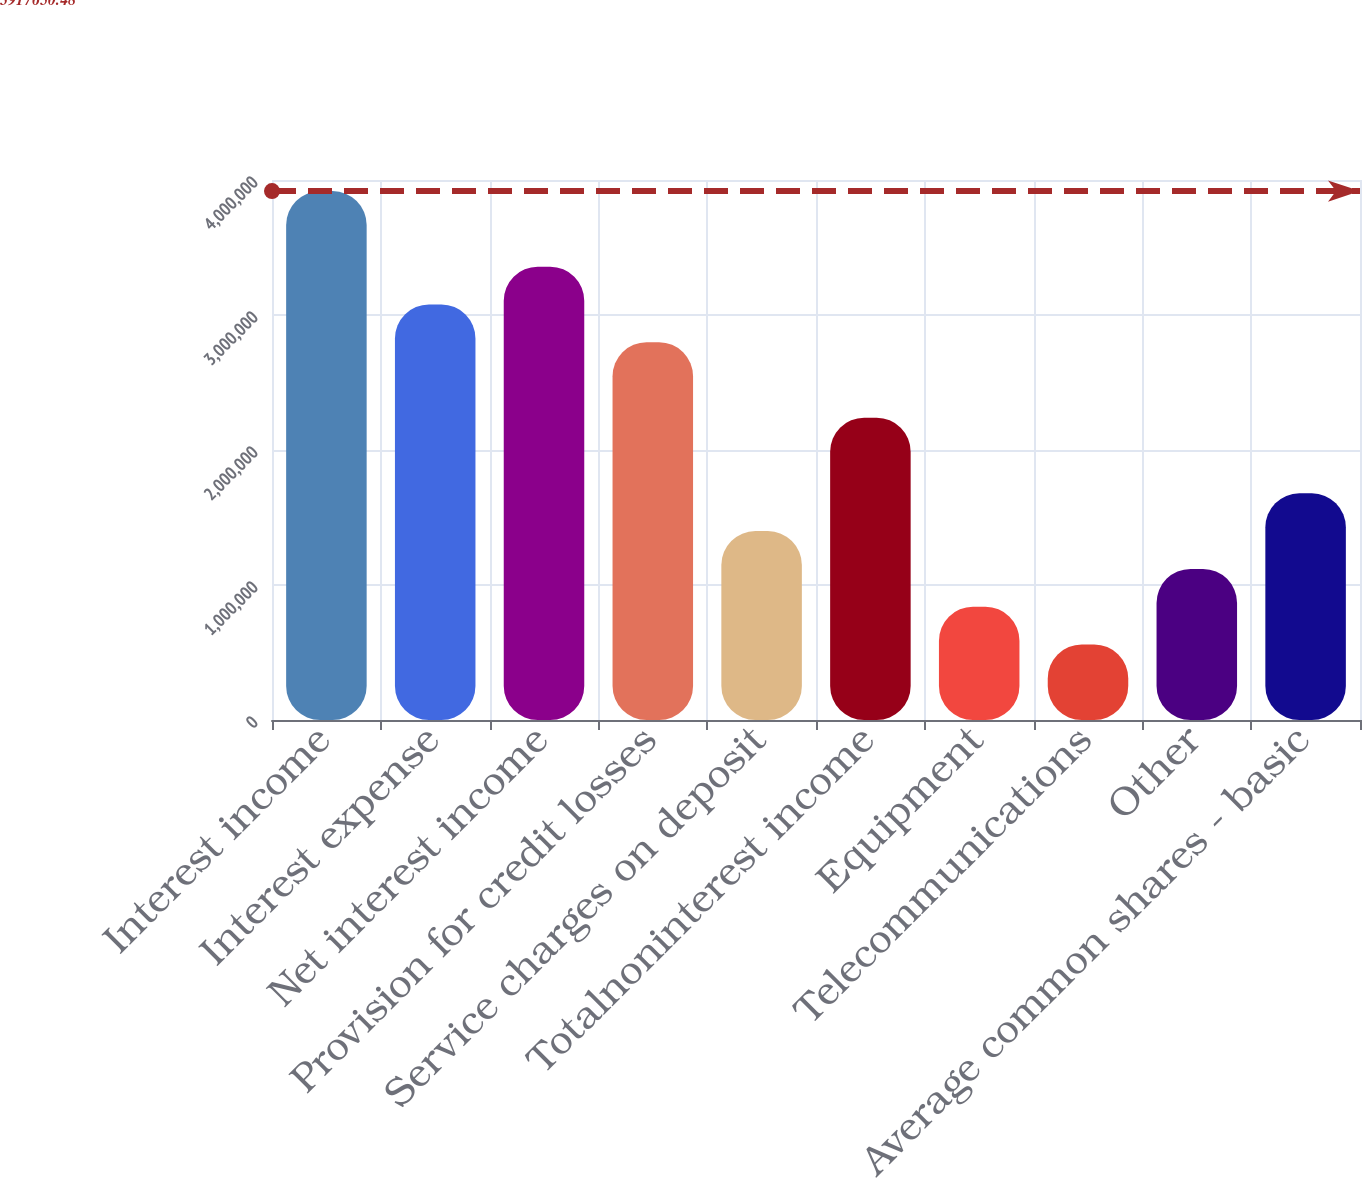<chart> <loc_0><loc_0><loc_500><loc_500><bar_chart><fcel>Interest income<fcel>Interest expense<fcel>Net interest income<fcel>Provision for credit losses<fcel>Service charges on deposit<fcel>Totalnoninterest income<fcel>Equipment<fcel>Telecommunications<fcel>Other<fcel>Average common shares - basic<nl><fcel>3.91765e+06<fcel>3.07815e+06<fcel>3.35799e+06<fcel>2.79832e+06<fcel>1.39916e+06<fcel>2.23866e+06<fcel>839497<fcel>559665<fcel>1.11933e+06<fcel>1.67899e+06<nl></chart> 